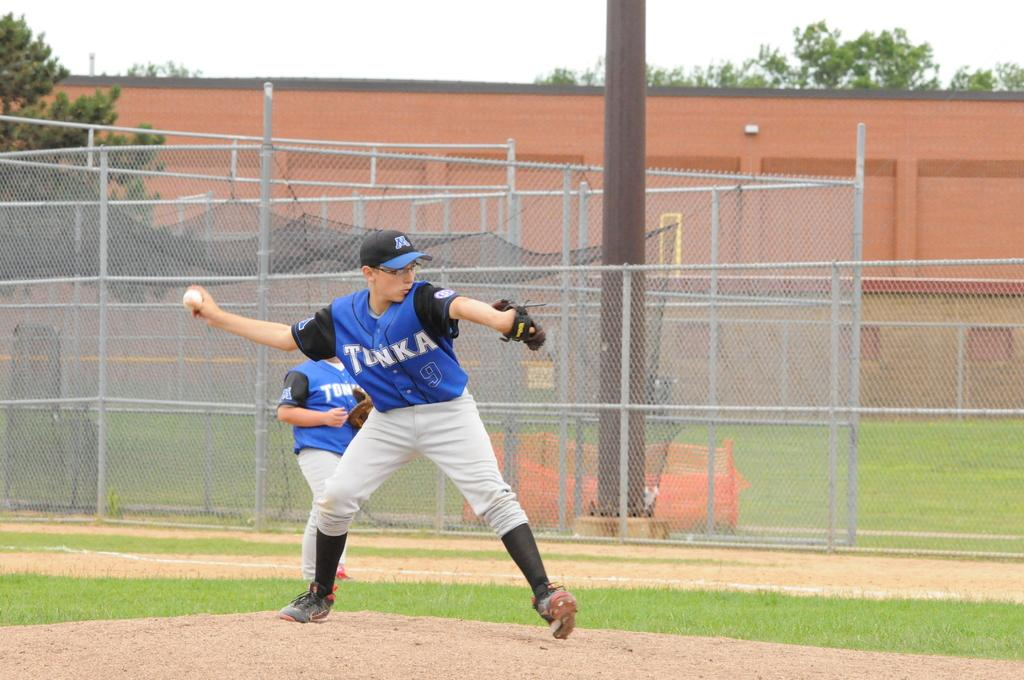<image>
Provide a brief description of the given image. Baseball player wearing a jersey saying TONKA about to pitch. 